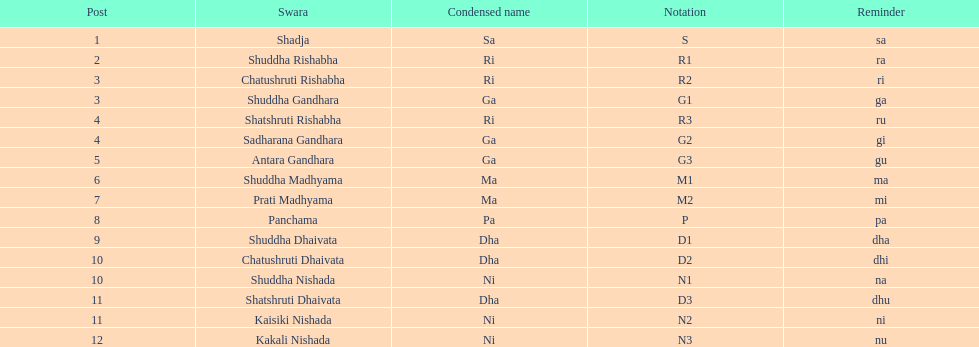What is the name of the swara that holds the first position? Shadja. 